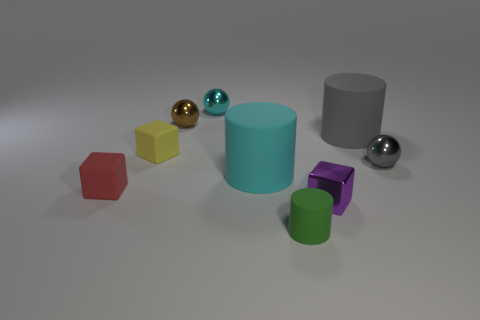What number of small spheres are on the left side of the cyan sphere?
Provide a short and direct response. 1. Are there more cyan spheres than tiny red metallic spheres?
Your answer should be very brief. Yes. There is a metal object that is both in front of the small brown shiny thing and to the left of the big gray cylinder; what is its shape?
Provide a short and direct response. Cube. Is there a tiny gray matte ball?
Offer a very short reply. No. What material is the green thing that is the same shape as the big gray thing?
Make the answer very short. Rubber. The big rubber object that is in front of the sphere that is in front of the matte thing that is to the right of the small green cylinder is what shape?
Give a very brief answer. Cylinder. What number of cyan matte objects are the same shape as the brown thing?
Keep it short and to the point. 0. Is the color of the tiny shiny ball that is left of the small cyan ball the same as the block to the right of the large cyan rubber cylinder?
Your answer should be compact. No. There is a green cylinder that is the same size as the gray shiny sphere; what is its material?
Offer a very short reply. Rubber. Are there any brown shiny cylinders of the same size as the red block?
Provide a succinct answer. No. 